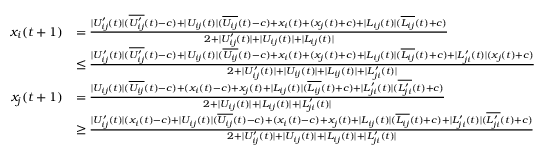Convert formula to latex. <formula><loc_0><loc_0><loc_500><loc_500>\begin{array} { r l } { x _ { i } ( t + 1 ) } & { = \frac { | U _ { i j } ^ { \prime } ( t ) | ( \overline { { U _ { i j } ^ { \prime } } } ( t ) - c ) + | U _ { i j } ( t ) | ( \overline { { U _ { i j } } } ( t ) - c ) + x _ { i } ( t ) + ( x _ { j } ( t ) + c ) + | L _ { i j } ( t ) | ( \overline { { L _ { i j } } } ( t ) + c ) } { 2 + | U _ { i j } ^ { \prime } ( t ) | + | U _ { i j } ( t ) | + | L _ { i j } ( t ) | } } \\ & { \leq \frac { | U _ { i j } ^ { \prime } ( t ) | ( \overline { { U _ { i j } ^ { \prime } } } ( t ) - c ) + | U _ { i j } ( t ) | ( \overline { { U _ { i j } } } ( t ) - c ) + x _ { i } ( t ) + ( x _ { j } ( t ) + c ) + | L _ { i j } ( t ) | ( \overline { { L _ { i j } } } ( t ) + c ) + | L _ { j i } ^ { \prime } ( t ) | ( x _ { j } ( t ) + c ) } { 2 + | U _ { i j } ^ { \prime } ( t ) | + | U _ { i j } ( t ) | + | L _ { i j } ( t ) | + | L _ { j i } ^ { \prime } ( t ) | } } \\ { x _ { j } ( t + 1 ) } & { = \frac { | U _ { i j } ( t ) | ( \overline { { U _ { i j } } } ( t ) - c ) + ( x _ { i } ( t ) - c ) + x _ { j } ( t ) + | L _ { i j } ( t ) | ( \overline { { L _ { i j } } } ( t ) + c ) + | L _ { j i } ^ { \prime } ( t ) | ( \overline { { L _ { j i } ^ { \prime } } } ( t ) + c ) } { 2 + | U _ { i j } ( t ) | + | L _ { i j } ( t ) | + | L _ { j i } ^ { \prime } ( t ) | } } \\ & { \geq \frac { | U _ { i j } ^ { \prime } ( t ) | ( x _ { i } ( t ) - c ) + | U _ { i j } ( t ) | ( \overline { { U _ { i j } } } ( t ) - c ) + ( x _ { i } ( t ) - c ) + x _ { j } ( t ) + | L _ { i j } ( t ) | ( \overline { { L _ { i j } } } ( t ) + c ) + | L _ { j i } ^ { \prime } ( t ) | ( \overline { { L _ { j i } ^ { \prime } } } ( t ) + c ) } { 2 + | U _ { i j } ^ { \prime } ( t ) | + | U _ { i j } ( t ) | + | L _ { i j } ( t ) | + | L _ { j i } ^ { \prime } ( t ) | } } \end{array}</formula> 